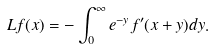<formula> <loc_0><loc_0><loc_500><loc_500>L f ( x ) = - \int _ { 0 } ^ { \infty } e ^ { - y } f ^ { \prime } ( x + y ) d y .</formula> 